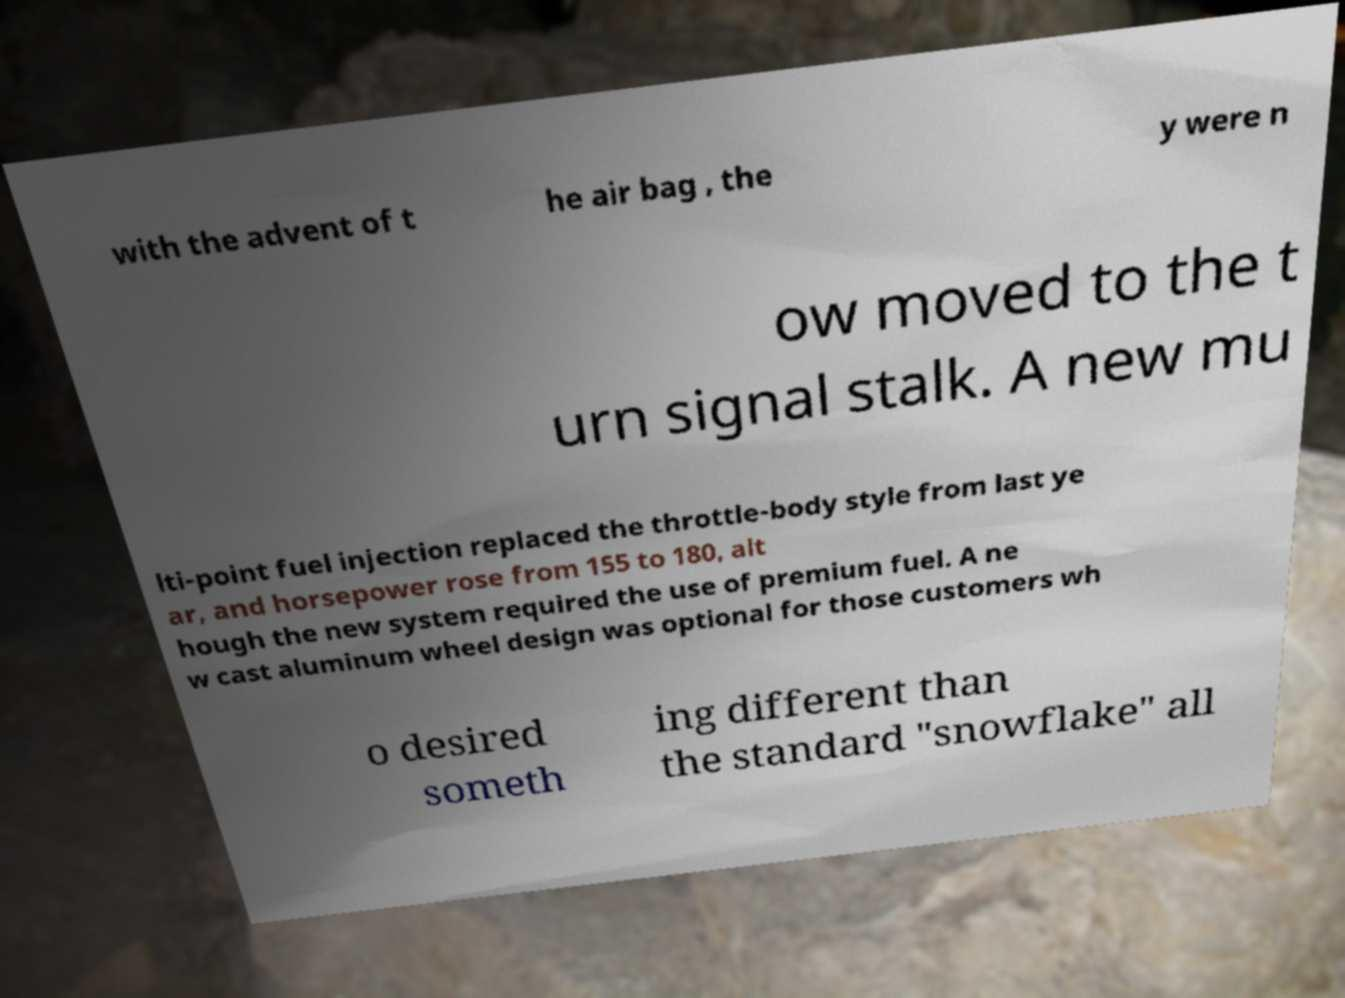Please read and relay the text visible in this image. What does it say? with the advent of t he air bag , the y were n ow moved to the t urn signal stalk. A new mu lti-point fuel injection replaced the throttle-body style from last ye ar, and horsepower rose from 155 to 180, alt hough the new system required the use of premium fuel. A ne w cast aluminum wheel design was optional for those customers wh o desired someth ing different than the standard "snowflake" all 